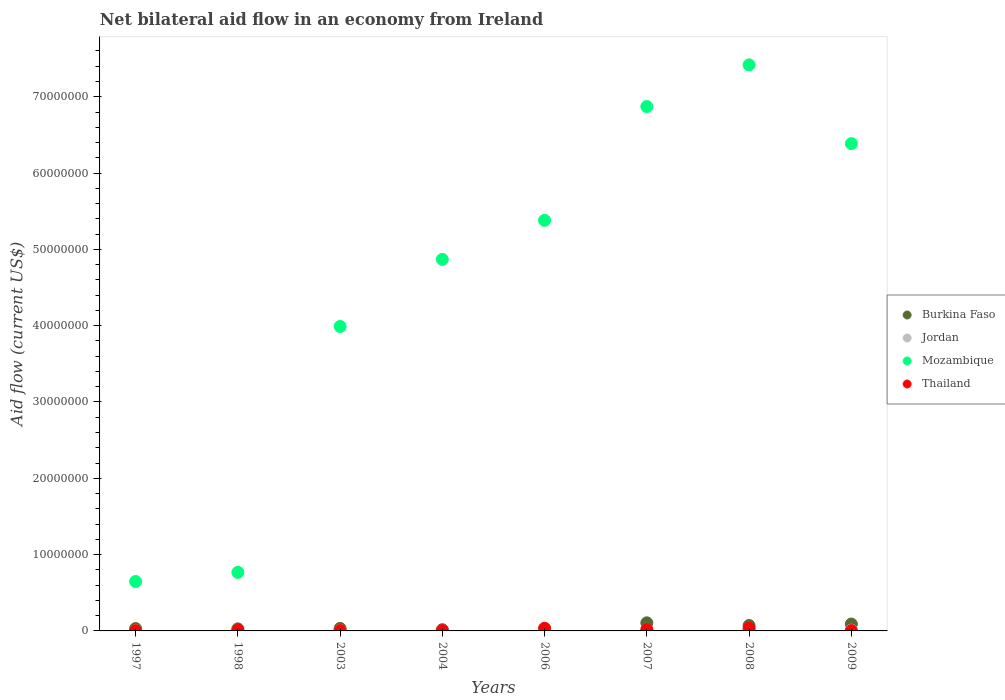How many different coloured dotlines are there?
Provide a short and direct response. 4. Is the number of dotlines equal to the number of legend labels?
Provide a short and direct response. Yes. Across all years, what is the maximum net bilateral aid flow in Burkina Faso?
Your answer should be very brief. 1.06e+06. In which year was the net bilateral aid flow in Mozambique maximum?
Ensure brevity in your answer.  2008. In which year was the net bilateral aid flow in Jordan minimum?
Ensure brevity in your answer.  1998. What is the total net bilateral aid flow in Mozambique in the graph?
Your answer should be very brief. 3.63e+08. What is the difference between the net bilateral aid flow in Burkina Faso in 2006 and the net bilateral aid flow in Thailand in 2004?
Ensure brevity in your answer.  3.00e+04. What is the average net bilateral aid flow in Mozambique per year?
Your response must be concise. 4.54e+07. In the year 2008, what is the difference between the net bilateral aid flow in Jordan and net bilateral aid flow in Burkina Faso?
Provide a succinct answer. -5.70e+05. What is the ratio of the net bilateral aid flow in Thailand in 1997 to that in 1998?
Provide a short and direct response. 0.4. Is the net bilateral aid flow in Burkina Faso in 2003 less than that in 2007?
Provide a succinct answer. Yes. What is the difference between the highest and the second highest net bilateral aid flow in Burkina Faso?
Your response must be concise. 1.60e+05. Is it the case that in every year, the sum of the net bilateral aid flow in Mozambique and net bilateral aid flow in Jordan  is greater than the net bilateral aid flow in Thailand?
Your answer should be very brief. Yes. Does the net bilateral aid flow in Burkina Faso monotonically increase over the years?
Your response must be concise. No. Is the net bilateral aid flow in Jordan strictly less than the net bilateral aid flow in Burkina Faso over the years?
Keep it short and to the point. No. How many years are there in the graph?
Offer a very short reply. 8. What is the difference between two consecutive major ticks on the Y-axis?
Offer a very short reply. 1.00e+07. Does the graph contain any zero values?
Offer a terse response. No. Does the graph contain grids?
Keep it short and to the point. No. Where does the legend appear in the graph?
Ensure brevity in your answer.  Center right. How many legend labels are there?
Your response must be concise. 4. How are the legend labels stacked?
Make the answer very short. Vertical. What is the title of the graph?
Your answer should be compact. Net bilateral aid flow in an economy from Ireland. Does "Serbia" appear as one of the legend labels in the graph?
Offer a very short reply. No. What is the Aid flow (current US$) in Mozambique in 1997?
Your answer should be compact. 6.48e+06. What is the Aid flow (current US$) of Jordan in 1998?
Your answer should be compact. 10000. What is the Aid flow (current US$) of Mozambique in 1998?
Offer a very short reply. 7.67e+06. What is the Aid flow (current US$) of Thailand in 1998?
Keep it short and to the point. 1.00e+05. What is the Aid flow (current US$) in Jordan in 2003?
Provide a short and direct response. 6.00e+04. What is the Aid flow (current US$) in Mozambique in 2003?
Offer a terse response. 3.99e+07. What is the Aid flow (current US$) of Jordan in 2004?
Make the answer very short. 10000. What is the Aid flow (current US$) of Mozambique in 2004?
Keep it short and to the point. 4.87e+07. What is the Aid flow (current US$) in Thailand in 2004?
Your response must be concise. 5.00e+04. What is the Aid flow (current US$) in Mozambique in 2006?
Your answer should be compact. 5.38e+07. What is the Aid flow (current US$) in Burkina Faso in 2007?
Ensure brevity in your answer.  1.06e+06. What is the Aid flow (current US$) of Mozambique in 2007?
Provide a short and direct response. 6.87e+07. What is the Aid flow (current US$) in Burkina Faso in 2008?
Your answer should be very brief. 7.10e+05. What is the Aid flow (current US$) in Mozambique in 2008?
Offer a very short reply. 7.42e+07. What is the Aid flow (current US$) of Thailand in 2008?
Keep it short and to the point. 3.50e+05. What is the Aid flow (current US$) of Jordan in 2009?
Make the answer very short. 1.00e+05. What is the Aid flow (current US$) of Mozambique in 2009?
Make the answer very short. 6.39e+07. Across all years, what is the maximum Aid flow (current US$) in Burkina Faso?
Provide a short and direct response. 1.06e+06. Across all years, what is the maximum Aid flow (current US$) of Mozambique?
Offer a very short reply. 7.42e+07. Across all years, what is the maximum Aid flow (current US$) of Thailand?
Make the answer very short. 3.50e+05. Across all years, what is the minimum Aid flow (current US$) of Burkina Faso?
Provide a succinct answer. 8.00e+04. Across all years, what is the minimum Aid flow (current US$) of Jordan?
Offer a very short reply. 10000. Across all years, what is the minimum Aid flow (current US$) of Mozambique?
Offer a terse response. 6.48e+06. What is the total Aid flow (current US$) of Burkina Faso in the graph?
Keep it short and to the point. 3.82e+06. What is the total Aid flow (current US$) in Jordan in the graph?
Make the answer very short. 7.50e+05. What is the total Aid flow (current US$) in Mozambique in the graph?
Make the answer very short. 3.63e+08. What is the total Aid flow (current US$) in Thailand in the graph?
Make the answer very short. 1.16e+06. What is the difference between the Aid flow (current US$) of Mozambique in 1997 and that in 1998?
Ensure brevity in your answer.  -1.19e+06. What is the difference between the Aid flow (current US$) in Burkina Faso in 1997 and that in 2003?
Provide a short and direct response. -2.00e+04. What is the difference between the Aid flow (current US$) of Jordan in 1997 and that in 2003?
Give a very brief answer. -2.00e+04. What is the difference between the Aid flow (current US$) of Mozambique in 1997 and that in 2003?
Give a very brief answer. -3.34e+07. What is the difference between the Aid flow (current US$) of Thailand in 1997 and that in 2003?
Make the answer very short. -10000. What is the difference between the Aid flow (current US$) of Burkina Faso in 1997 and that in 2004?
Ensure brevity in your answer.  1.50e+05. What is the difference between the Aid flow (current US$) in Mozambique in 1997 and that in 2004?
Offer a very short reply. -4.22e+07. What is the difference between the Aid flow (current US$) of Burkina Faso in 1997 and that in 2006?
Offer a very short reply. 2.30e+05. What is the difference between the Aid flow (current US$) in Jordan in 1997 and that in 2006?
Provide a short and direct response. -2.10e+05. What is the difference between the Aid flow (current US$) of Mozambique in 1997 and that in 2006?
Provide a succinct answer. -4.73e+07. What is the difference between the Aid flow (current US$) of Thailand in 1997 and that in 2006?
Offer a very short reply. -3.10e+05. What is the difference between the Aid flow (current US$) of Burkina Faso in 1997 and that in 2007?
Keep it short and to the point. -7.50e+05. What is the difference between the Aid flow (current US$) of Jordan in 1997 and that in 2007?
Give a very brief answer. -1.00e+05. What is the difference between the Aid flow (current US$) in Mozambique in 1997 and that in 2007?
Your answer should be very brief. -6.22e+07. What is the difference between the Aid flow (current US$) in Thailand in 1997 and that in 2007?
Your answer should be very brief. -1.40e+05. What is the difference between the Aid flow (current US$) in Burkina Faso in 1997 and that in 2008?
Offer a very short reply. -4.00e+05. What is the difference between the Aid flow (current US$) of Jordan in 1997 and that in 2008?
Your response must be concise. -1.00e+05. What is the difference between the Aid flow (current US$) of Mozambique in 1997 and that in 2008?
Offer a terse response. -6.77e+07. What is the difference between the Aid flow (current US$) of Thailand in 1997 and that in 2008?
Your answer should be very brief. -3.10e+05. What is the difference between the Aid flow (current US$) of Burkina Faso in 1997 and that in 2009?
Ensure brevity in your answer.  -5.90e+05. What is the difference between the Aid flow (current US$) in Jordan in 1997 and that in 2009?
Give a very brief answer. -6.00e+04. What is the difference between the Aid flow (current US$) of Mozambique in 1997 and that in 2009?
Provide a short and direct response. -5.74e+07. What is the difference between the Aid flow (current US$) in Mozambique in 1998 and that in 2003?
Offer a very short reply. -3.22e+07. What is the difference between the Aid flow (current US$) in Thailand in 1998 and that in 2003?
Keep it short and to the point. 5.00e+04. What is the difference between the Aid flow (current US$) in Burkina Faso in 1998 and that in 2004?
Keep it short and to the point. 1.10e+05. What is the difference between the Aid flow (current US$) in Jordan in 1998 and that in 2004?
Keep it short and to the point. 0. What is the difference between the Aid flow (current US$) in Mozambique in 1998 and that in 2004?
Make the answer very short. -4.10e+07. What is the difference between the Aid flow (current US$) of Burkina Faso in 1998 and that in 2006?
Keep it short and to the point. 1.90e+05. What is the difference between the Aid flow (current US$) in Jordan in 1998 and that in 2006?
Your answer should be very brief. -2.40e+05. What is the difference between the Aid flow (current US$) of Mozambique in 1998 and that in 2006?
Make the answer very short. -4.61e+07. What is the difference between the Aid flow (current US$) of Thailand in 1998 and that in 2006?
Keep it short and to the point. -2.50e+05. What is the difference between the Aid flow (current US$) of Burkina Faso in 1998 and that in 2007?
Keep it short and to the point. -7.90e+05. What is the difference between the Aid flow (current US$) of Jordan in 1998 and that in 2007?
Keep it short and to the point. -1.30e+05. What is the difference between the Aid flow (current US$) of Mozambique in 1998 and that in 2007?
Provide a succinct answer. -6.10e+07. What is the difference between the Aid flow (current US$) in Thailand in 1998 and that in 2007?
Give a very brief answer. -8.00e+04. What is the difference between the Aid flow (current US$) of Burkina Faso in 1998 and that in 2008?
Make the answer very short. -4.40e+05. What is the difference between the Aid flow (current US$) in Jordan in 1998 and that in 2008?
Offer a terse response. -1.30e+05. What is the difference between the Aid flow (current US$) of Mozambique in 1998 and that in 2008?
Keep it short and to the point. -6.65e+07. What is the difference between the Aid flow (current US$) in Burkina Faso in 1998 and that in 2009?
Keep it short and to the point. -6.30e+05. What is the difference between the Aid flow (current US$) of Jordan in 1998 and that in 2009?
Your answer should be very brief. -9.00e+04. What is the difference between the Aid flow (current US$) of Mozambique in 1998 and that in 2009?
Your answer should be very brief. -5.62e+07. What is the difference between the Aid flow (current US$) in Thailand in 1998 and that in 2009?
Your answer should be very brief. 6.00e+04. What is the difference between the Aid flow (current US$) of Mozambique in 2003 and that in 2004?
Your answer should be compact. -8.79e+06. What is the difference between the Aid flow (current US$) of Mozambique in 2003 and that in 2006?
Your answer should be compact. -1.39e+07. What is the difference between the Aid flow (current US$) of Thailand in 2003 and that in 2006?
Your answer should be compact. -3.00e+05. What is the difference between the Aid flow (current US$) in Burkina Faso in 2003 and that in 2007?
Your answer should be compact. -7.30e+05. What is the difference between the Aid flow (current US$) in Jordan in 2003 and that in 2007?
Your response must be concise. -8.00e+04. What is the difference between the Aid flow (current US$) of Mozambique in 2003 and that in 2007?
Ensure brevity in your answer.  -2.88e+07. What is the difference between the Aid flow (current US$) in Thailand in 2003 and that in 2007?
Provide a short and direct response. -1.30e+05. What is the difference between the Aid flow (current US$) of Burkina Faso in 2003 and that in 2008?
Your answer should be very brief. -3.80e+05. What is the difference between the Aid flow (current US$) of Mozambique in 2003 and that in 2008?
Your response must be concise. -3.43e+07. What is the difference between the Aid flow (current US$) in Thailand in 2003 and that in 2008?
Ensure brevity in your answer.  -3.00e+05. What is the difference between the Aid flow (current US$) in Burkina Faso in 2003 and that in 2009?
Make the answer very short. -5.70e+05. What is the difference between the Aid flow (current US$) in Mozambique in 2003 and that in 2009?
Ensure brevity in your answer.  -2.40e+07. What is the difference between the Aid flow (current US$) of Thailand in 2003 and that in 2009?
Ensure brevity in your answer.  10000. What is the difference between the Aid flow (current US$) in Mozambique in 2004 and that in 2006?
Your answer should be very brief. -5.12e+06. What is the difference between the Aid flow (current US$) of Thailand in 2004 and that in 2006?
Give a very brief answer. -3.00e+05. What is the difference between the Aid flow (current US$) of Burkina Faso in 2004 and that in 2007?
Offer a very short reply. -9.00e+05. What is the difference between the Aid flow (current US$) of Jordan in 2004 and that in 2007?
Offer a very short reply. -1.30e+05. What is the difference between the Aid flow (current US$) in Mozambique in 2004 and that in 2007?
Provide a short and direct response. -2.00e+07. What is the difference between the Aid flow (current US$) in Burkina Faso in 2004 and that in 2008?
Your response must be concise. -5.50e+05. What is the difference between the Aid flow (current US$) of Jordan in 2004 and that in 2008?
Keep it short and to the point. -1.30e+05. What is the difference between the Aid flow (current US$) in Mozambique in 2004 and that in 2008?
Make the answer very short. -2.55e+07. What is the difference between the Aid flow (current US$) in Thailand in 2004 and that in 2008?
Make the answer very short. -3.00e+05. What is the difference between the Aid flow (current US$) of Burkina Faso in 2004 and that in 2009?
Your response must be concise. -7.40e+05. What is the difference between the Aid flow (current US$) of Mozambique in 2004 and that in 2009?
Your answer should be compact. -1.52e+07. What is the difference between the Aid flow (current US$) in Thailand in 2004 and that in 2009?
Make the answer very short. 10000. What is the difference between the Aid flow (current US$) of Burkina Faso in 2006 and that in 2007?
Provide a short and direct response. -9.80e+05. What is the difference between the Aid flow (current US$) in Mozambique in 2006 and that in 2007?
Your response must be concise. -1.49e+07. What is the difference between the Aid flow (current US$) of Burkina Faso in 2006 and that in 2008?
Your response must be concise. -6.30e+05. What is the difference between the Aid flow (current US$) of Mozambique in 2006 and that in 2008?
Keep it short and to the point. -2.04e+07. What is the difference between the Aid flow (current US$) in Burkina Faso in 2006 and that in 2009?
Keep it short and to the point. -8.20e+05. What is the difference between the Aid flow (current US$) of Jordan in 2006 and that in 2009?
Give a very brief answer. 1.50e+05. What is the difference between the Aid flow (current US$) of Mozambique in 2006 and that in 2009?
Offer a very short reply. -1.00e+07. What is the difference between the Aid flow (current US$) of Thailand in 2006 and that in 2009?
Offer a very short reply. 3.10e+05. What is the difference between the Aid flow (current US$) of Burkina Faso in 2007 and that in 2008?
Your answer should be compact. 3.50e+05. What is the difference between the Aid flow (current US$) of Mozambique in 2007 and that in 2008?
Ensure brevity in your answer.  -5.46e+06. What is the difference between the Aid flow (current US$) in Thailand in 2007 and that in 2008?
Ensure brevity in your answer.  -1.70e+05. What is the difference between the Aid flow (current US$) in Burkina Faso in 2007 and that in 2009?
Provide a short and direct response. 1.60e+05. What is the difference between the Aid flow (current US$) of Jordan in 2007 and that in 2009?
Keep it short and to the point. 4.00e+04. What is the difference between the Aid flow (current US$) in Mozambique in 2007 and that in 2009?
Your answer should be very brief. 4.86e+06. What is the difference between the Aid flow (current US$) of Thailand in 2007 and that in 2009?
Keep it short and to the point. 1.40e+05. What is the difference between the Aid flow (current US$) in Burkina Faso in 2008 and that in 2009?
Give a very brief answer. -1.90e+05. What is the difference between the Aid flow (current US$) of Mozambique in 2008 and that in 2009?
Provide a succinct answer. 1.03e+07. What is the difference between the Aid flow (current US$) in Burkina Faso in 1997 and the Aid flow (current US$) in Jordan in 1998?
Your answer should be very brief. 3.00e+05. What is the difference between the Aid flow (current US$) in Burkina Faso in 1997 and the Aid flow (current US$) in Mozambique in 1998?
Your answer should be very brief. -7.36e+06. What is the difference between the Aid flow (current US$) of Jordan in 1997 and the Aid flow (current US$) of Mozambique in 1998?
Give a very brief answer. -7.63e+06. What is the difference between the Aid flow (current US$) of Jordan in 1997 and the Aid flow (current US$) of Thailand in 1998?
Give a very brief answer. -6.00e+04. What is the difference between the Aid flow (current US$) of Mozambique in 1997 and the Aid flow (current US$) of Thailand in 1998?
Offer a very short reply. 6.38e+06. What is the difference between the Aid flow (current US$) in Burkina Faso in 1997 and the Aid flow (current US$) in Mozambique in 2003?
Your answer should be compact. -3.96e+07. What is the difference between the Aid flow (current US$) in Jordan in 1997 and the Aid flow (current US$) in Mozambique in 2003?
Your answer should be compact. -3.99e+07. What is the difference between the Aid flow (current US$) in Jordan in 1997 and the Aid flow (current US$) in Thailand in 2003?
Ensure brevity in your answer.  -10000. What is the difference between the Aid flow (current US$) in Mozambique in 1997 and the Aid flow (current US$) in Thailand in 2003?
Offer a terse response. 6.43e+06. What is the difference between the Aid flow (current US$) in Burkina Faso in 1997 and the Aid flow (current US$) in Mozambique in 2004?
Make the answer very short. -4.84e+07. What is the difference between the Aid flow (current US$) in Jordan in 1997 and the Aid flow (current US$) in Mozambique in 2004?
Ensure brevity in your answer.  -4.86e+07. What is the difference between the Aid flow (current US$) of Mozambique in 1997 and the Aid flow (current US$) of Thailand in 2004?
Provide a succinct answer. 6.43e+06. What is the difference between the Aid flow (current US$) of Burkina Faso in 1997 and the Aid flow (current US$) of Jordan in 2006?
Offer a very short reply. 6.00e+04. What is the difference between the Aid flow (current US$) of Burkina Faso in 1997 and the Aid flow (current US$) of Mozambique in 2006?
Your response must be concise. -5.35e+07. What is the difference between the Aid flow (current US$) of Jordan in 1997 and the Aid flow (current US$) of Mozambique in 2006?
Make the answer very short. -5.38e+07. What is the difference between the Aid flow (current US$) in Jordan in 1997 and the Aid flow (current US$) in Thailand in 2006?
Your answer should be very brief. -3.10e+05. What is the difference between the Aid flow (current US$) of Mozambique in 1997 and the Aid flow (current US$) of Thailand in 2006?
Offer a very short reply. 6.13e+06. What is the difference between the Aid flow (current US$) of Burkina Faso in 1997 and the Aid flow (current US$) of Mozambique in 2007?
Provide a succinct answer. -6.84e+07. What is the difference between the Aid flow (current US$) of Burkina Faso in 1997 and the Aid flow (current US$) of Thailand in 2007?
Your response must be concise. 1.30e+05. What is the difference between the Aid flow (current US$) in Jordan in 1997 and the Aid flow (current US$) in Mozambique in 2007?
Offer a very short reply. -6.87e+07. What is the difference between the Aid flow (current US$) in Jordan in 1997 and the Aid flow (current US$) in Thailand in 2007?
Make the answer very short. -1.40e+05. What is the difference between the Aid flow (current US$) of Mozambique in 1997 and the Aid flow (current US$) of Thailand in 2007?
Offer a very short reply. 6.30e+06. What is the difference between the Aid flow (current US$) in Burkina Faso in 1997 and the Aid flow (current US$) in Jordan in 2008?
Offer a terse response. 1.70e+05. What is the difference between the Aid flow (current US$) of Burkina Faso in 1997 and the Aid flow (current US$) of Mozambique in 2008?
Your answer should be very brief. -7.39e+07. What is the difference between the Aid flow (current US$) in Jordan in 1997 and the Aid flow (current US$) in Mozambique in 2008?
Offer a terse response. -7.41e+07. What is the difference between the Aid flow (current US$) of Jordan in 1997 and the Aid flow (current US$) of Thailand in 2008?
Offer a terse response. -3.10e+05. What is the difference between the Aid flow (current US$) of Mozambique in 1997 and the Aid flow (current US$) of Thailand in 2008?
Ensure brevity in your answer.  6.13e+06. What is the difference between the Aid flow (current US$) in Burkina Faso in 1997 and the Aid flow (current US$) in Mozambique in 2009?
Your answer should be compact. -6.36e+07. What is the difference between the Aid flow (current US$) in Jordan in 1997 and the Aid flow (current US$) in Mozambique in 2009?
Your answer should be compact. -6.38e+07. What is the difference between the Aid flow (current US$) of Jordan in 1997 and the Aid flow (current US$) of Thailand in 2009?
Offer a terse response. 0. What is the difference between the Aid flow (current US$) of Mozambique in 1997 and the Aid flow (current US$) of Thailand in 2009?
Keep it short and to the point. 6.44e+06. What is the difference between the Aid flow (current US$) in Burkina Faso in 1998 and the Aid flow (current US$) in Jordan in 2003?
Offer a terse response. 2.10e+05. What is the difference between the Aid flow (current US$) in Burkina Faso in 1998 and the Aid flow (current US$) in Mozambique in 2003?
Your answer should be compact. -3.96e+07. What is the difference between the Aid flow (current US$) of Burkina Faso in 1998 and the Aid flow (current US$) of Thailand in 2003?
Make the answer very short. 2.20e+05. What is the difference between the Aid flow (current US$) of Jordan in 1998 and the Aid flow (current US$) of Mozambique in 2003?
Provide a short and direct response. -3.99e+07. What is the difference between the Aid flow (current US$) in Mozambique in 1998 and the Aid flow (current US$) in Thailand in 2003?
Give a very brief answer. 7.62e+06. What is the difference between the Aid flow (current US$) in Burkina Faso in 1998 and the Aid flow (current US$) in Mozambique in 2004?
Offer a terse response. -4.84e+07. What is the difference between the Aid flow (current US$) of Jordan in 1998 and the Aid flow (current US$) of Mozambique in 2004?
Offer a terse response. -4.87e+07. What is the difference between the Aid flow (current US$) in Jordan in 1998 and the Aid flow (current US$) in Thailand in 2004?
Offer a terse response. -4.00e+04. What is the difference between the Aid flow (current US$) in Mozambique in 1998 and the Aid flow (current US$) in Thailand in 2004?
Provide a short and direct response. 7.62e+06. What is the difference between the Aid flow (current US$) of Burkina Faso in 1998 and the Aid flow (current US$) of Mozambique in 2006?
Provide a short and direct response. -5.35e+07. What is the difference between the Aid flow (current US$) of Burkina Faso in 1998 and the Aid flow (current US$) of Thailand in 2006?
Your answer should be very brief. -8.00e+04. What is the difference between the Aid flow (current US$) of Jordan in 1998 and the Aid flow (current US$) of Mozambique in 2006?
Make the answer very short. -5.38e+07. What is the difference between the Aid flow (current US$) of Jordan in 1998 and the Aid flow (current US$) of Thailand in 2006?
Your answer should be very brief. -3.40e+05. What is the difference between the Aid flow (current US$) in Mozambique in 1998 and the Aid flow (current US$) in Thailand in 2006?
Ensure brevity in your answer.  7.32e+06. What is the difference between the Aid flow (current US$) in Burkina Faso in 1998 and the Aid flow (current US$) in Mozambique in 2007?
Keep it short and to the point. -6.84e+07. What is the difference between the Aid flow (current US$) of Jordan in 1998 and the Aid flow (current US$) of Mozambique in 2007?
Offer a very short reply. -6.87e+07. What is the difference between the Aid flow (current US$) in Jordan in 1998 and the Aid flow (current US$) in Thailand in 2007?
Your answer should be very brief. -1.70e+05. What is the difference between the Aid flow (current US$) in Mozambique in 1998 and the Aid flow (current US$) in Thailand in 2007?
Provide a short and direct response. 7.49e+06. What is the difference between the Aid flow (current US$) in Burkina Faso in 1998 and the Aid flow (current US$) in Jordan in 2008?
Your answer should be compact. 1.30e+05. What is the difference between the Aid flow (current US$) of Burkina Faso in 1998 and the Aid flow (current US$) of Mozambique in 2008?
Your answer should be compact. -7.39e+07. What is the difference between the Aid flow (current US$) of Jordan in 1998 and the Aid flow (current US$) of Mozambique in 2008?
Your answer should be very brief. -7.42e+07. What is the difference between the Aid flow (current US$) of Jordan in 1998 and the Aid flow (current US$) of Thailand in 2008?
Your response must be concise. -3.40e+05. What is the difference between the Aid flow (current US$) of Mozambique in 1998 and the Aid flow (current US$) of Thailand in 2008?
Make the answer very short. 7.32e+06. What is the difference between the Aid flow (current US$) in Burkina Faso in 1998 and the Aid flow (current US$) in Mozambique in 2009?
Your response must be concise. -6.36e+07. What is the difference between the Aid flow (current US$) of Burkina Faso in 1998 and the Aid flow (current US$) of Thailand in 2009?
Give a very brief answer. 2.30e+05. What is the difference between the Aid flow (current US$) in Jordan in 1998 and the Aid flow (current US$) in Mozambique in 2009?
Your answer should be compact. -6.38e+07. What is the difference between the Aid flow (current US$) in Jordan in 1998 and the Aid flow (current US$) in Thailand in 2009?
Keep it short and to the point. -3.00e+04. What is the difference between the Aid flow (current US$) in Mozambique in 1998 and the Aid flow (current US$) in Thailand in 2009?
Your answer should be very brief. 7.63e+06. What is the difference between the Aid flow (current US$) in Burkina Faso in 2003 and the Aid flow (current US$) in Jordan in 2004?
Make the answer very short. 3.20e+05. What is the difference between the Aid flow (current US$) in Burkina Faso in 2003 and the Aid flow (current US$) in Mozambique in 2004?
Offer a very short reply. -4.84e+07. What is the difference between the Aid flow (current US$) in Burkina Faso in 2003 and the Aid flow (current US$) in Thailand in 2004?
Your response must be concise. 2.80e+05. What is the difference between the Aid flow (current US$) in Jordan in 2003 and the Aid flow (current US$) in Mozambique in 2004?
Provide a succinct answer. -4.86e+07. What is the difference between the Aid flow (current US$) of Jordan in 2003 and the Aid flow (current US$) of Thailand in 2004?
Ensure brevity in your answer.  10000. What is the difference between the Aid flow (current US$) in Mozambique in 2003 and the Aid flow (current US$) in Thailand in 2004?
Offer a terse response. 3.98e+07. What is the difference between the Aid flow (current US$) of Burkina Faso in 2003 and the Aid flow (current US$) of Mozambique in 2006?
Offer a very short reply. -5.35e+07. What is the difference between the Aid flow (current US$) of Burkina Faso in 2003 and the Aid flow (current US$) of Thailand in 2006?
Provide a short and direct response. -2.00e+04. What is the difference between the Aid flow (current US$) in Jordan in 2003 and the Aid flow (current US$) in Mozambique in 2006?
Provide a succinct answer. -5.38e+07. What is the difference between the Aid flow (current US$) in Jordan in 2003 and the Aid flow (current US$) in Thailand in 2006?
Keep it short and to the point. -2.90e+05. What is the difference between the Aid flow (current US$) in Mozambique in 2003 and the Aid flow (current US$) in Thailand in 2006?
Your answer should be compact. 3.96e+07. What is the difference between the Aid flow (current US$) in Burkina Faso in 2003 and the Aid flow (current US$) in Jordan in 2007?
Your answer should be compact. 1.90e+05. What is the difference between the Aid flow (current US$) in Burkina Faso in 2003 and the Aid flow (current US$) in Mozambique in 2007?
Provide a succinct answer. -6.84e+07. What is the difference between the Aid flow (current US$) in Jordan in 2003 and the Aid flow (current US$) in Mozambique in 2007?
Offer a very short reply. -6.87e+07. What is the difference between the Aid flow (current US$) in Jordan in 2003 and the Aid flow (current US$) in Thailand in 2007?
Offer a terse response. -1.20e+05. What is the difference between the Aid flow (current US$) of Mozambique in 2003 and the Aid flow (current US$) of Thailand in 2007?
Your response must be concise. 3.97e+07. What is the difference between the Aid flow (current US$) of Burkina Faso in 2003 and the Aid flow (current US$) of Jordan in 2008?
Provide a succinct answer. 1.90e+05. What is the difference between the Aid flow (current US$) in Burkina Faso in 2003 and the Aid flow (current US$) in Mozambique in 2008?
Keep it short and to the point. -7.38e+07. What is the difference between the Aid flow (current US$) of Jordan in 2003 and the Aid flow (current US$) of Mozambique in 2008?
Make the answer very short. -7.41e+07. What is the difference between the Aid flow (current US$) in Jordan in 2003 and the Aid flow (current US$) in Thailand in 2008?
Provide a succinct answer. -2.90e+05. What is the difference between the Aid flow (current US$) of Mozambique in 2003 and the Aid flow (current US$) of Thailand in 2008?
Your answer should be very brief. 3.96e+07. What is the difference between the Aid flow (current US$) in Burkina Faso in 2003 and the Aid flow (current US$) in Jordan in 2009?
Your answer should be very brief. 2.30e+05. What is the difference between the Aid flow (current US$) of Burkina Faso in 2003 and the Aid flow (current US$) of Mozambique in 2009?
Your response must be concise. -6.35e+07. What is the difference between the Aid flow (current US$) of Burkina Faso in 2003 and the Aid flow (current US$) of Thailand in 2009?
Your answer should be very brief. 2.90e+05. What is the difference between the Aid flow (current US$) of Jordan in 2003 and the Aid flow (current US$) of Mozambique in 2009?
Offer a terse response. -6.38e+07. What is the difference between the Aid flow (current US$) in Jordan in 2003 and the Aid flow (current US$) in Thailand in 2009?
Make the answer very short. 2.00e+04. What is the difference between the Aid flow (current US$) in Mozambique in 2003 and the Aid flow (current US$) in Thailand in 2009?
Your answer should be compact. 3.99e+07. What is the difference between the Aid flow (current US$) in Burkina Faso in 2004 and the Aid flow (current US$) in Jordan in 2006?
Provide a short and direct response. -9.00e+04. What is the difference between the Aid flow (current US$) of Burkina Faso in 2004 and the Aid flow (current US$) of Mozambique in 2006?
Offer a very short reply. -5.36e+07. What is the difference between the Aid flow (current US$) of Burkina Faso in 2004 and the Aid flow (current US$) of Thailand in 2006?
Give a very brief answer. -1.90e+05. What is the difference between the Aid flow (current US$) in Jordan in 2004 and the Aid flow (current US$) in Mozambique in 2006?
Provide a succinct answer. -5.38e+07. What is the difference between the Aid flow (current US$) in Jordan in 2004 and the Aid flow (current US$) in Thailand in 2006?
Provide a short and direct response. -3.40e+05. What is the difference between the Aid flow (current US$) of Mozambique in 2004 and the Aid flow (current US$) of Thailand in 2006?
Give a very brief answer. 4.83e+07. What is the difference between the Aid flow (current US$) in Burkina Faso in 2004 and the Aid flow (current US$) in Jordan in 2007?
Make the answer very short. 2.00e+04. What is the difference between the Aid flow (current US$) of Burkina Faso in 2004 and the Aid flow (current US$) of Mozambique in 2007?
Give a very brief answer. -6.86e+07. What is the difference between the Aid flow (current US$) of Jordan in 2004 and the Aid flow (current US$) of Mozambique in 2007?
Your response must be concise. -6.87e+07. What is the difference between the Aid flow (current US$) in Mozambique in 2004 and the Aid flow (current US$) in Thailand in 2007?
Make the answer very short. 4.85e+07. What is the difference between the Aid flow (current US$) in Burkina Faso in 2004 and the Aid flow (current US$) in Mozambique in 2008?
Keep it short and to the point. -7.40e+07. What is the difference between the Aid flow (current US$) in Jordan in 2004 and the Aid flow (current US$) in Mozambique in 2008?
Your answer should be compact. -7.42e+07. What is the difference between the Aid flow (current US$) in Jordan in 2004 and the Aid flow (current US$) in Thailand in 2008?
Your answer should be compact. -3.40e+05. What is the difference between the Aid flow (current US$) of Mozambique in 2004 and the Aid flow (current US$) of Thailand in 2008?
Your answer should be compact. 4.83e+07. What is the difference between the Aid flow (current US$) in Burkina Faso in 2004 and the Aid flow (current US$) in Mozambique in 2009?
Your answer should be very brief. -6.37e+07. What is the difference between the Aid flow (current US$) in Burkina Faso in 2004 and the Aid flow (current US$) in Thailand in 2009?
Your answer should be compact. 1.20e+05. What is the difference between the Aid flow (current US$) in Jordan in 2004 and the Aid flow (current US$) in Mozambique in 2009?
Provide a succinct answer. -6.38e+07. What is the difference between the Aid flow (current US$) in Mozambique in 2004 and the Aid flow (current US$) in Thailand in 2009?
Provide a succinct answer. 4.86e+07. What is the difference between the Aid flow (current US$) of Burkina Faso in 2006 and the Aid flow (current US$) of Mozambique in 2007?
Make the answer very short. -6.86e+07. What is the difference between the Aid flow (current US$) of Jordan in 2006 and the Aid flow (current US$) of Mozambique in 2007?
Make the answer very short. -6.85e+07. What is the difference between the Aid flow (current US$) in Jordan in 2006 and the Aid flow (current US$) in Thailand in 2007?
Make the answer very short. 7.00e+04. What is the difference between the Aid flow (current US$) in Mozambique in 2006 and the Aid flow (current US$) in Thailand in 2007?
Offer a very short reply. 5.36e+07. What is the difference between the Aid flow (current US$) of Burkina Faso in 2006 and the Aid flow (current US$) of Jordan in 2008?
Make the answer very short. -6.00e+04. What is the difference between the Aid flow (current US$) in Burkina Faso in 2006 and the Aid flow (current US$) in Mozambique in 2008?
Offer a terse response. -7.41e+07. What is the difference between the Aid flow (current US$) of Burkina Faso in 2006 and the Aid flow (current US$) of Thailand in 2008?
Provide a succinct answer. -2.70e+05. What is the difference between the Aid flow (current US$) of Jordan in 2006 and the Aid flow (current US$) of Mozambique in 2008?
Provide a succinct answer. -7.39e+07. What is the difference between the Aid flow (current US$) of Mozambique in 2006 and the Aid flow (current US$) of Thailand in 2008?
Keep it short and to the point. 5.35e+07. What is the difference between the Aid flow (current US$) in Burkina Faso in 2006 and the Aid flow (current US$) in Jordan in 2009?
Provide a short and direct response. -2.00e+04. What is the difference between the Aid flow (current US$) of Burkina Faso in 2006 and the Aid flow (current US$) of Mozambique in 2009?
Your answer should be compact. -6.38e+07. What is the difference between the Aid flow (current US$) of Jordan in 2006 and the Aid flow (current US$) of Mozambique in 2009?
Provide a short and direct response. -6.36e+07. What is the difference between the Aid flow (current US$) in Mozambique in 2006 and the Aid flow (current US$) in Thailand in 2009?
Ensure brevity in your answer.  5.38e+07. What is the difference between the Aid flow (current US$) in Burkina Faso in 2007 and the Aid flow (current US$) in Jordan in 2008?
Your answer should be compact. 9.20e+05. What is the difference between the Aid flow (current US$) in Burkina Faso in 2007 and the Aid flow (current US$) in Mozambique in 2008?
Give a very brief answer. -7.31e+07. What is the difference between the Aid flow (current US$) in Burkina Faso in 2007 and the Aid flow (current US$) in Thailand in 2008?
Your answer should be very brief. 7.10e+05. What is the difference between the Aid flow (current US$) in Jordan in 2007 and the Aid flow (current US$) in Mozambique in 2008?
Ensure brevity in your answer.  -7.40e+07. What is the difference between the Aid flow (current US$) in Jordan in 2007 and the Aid flow (current US$) in Thailand in 2008?
Your answer should be very brief. -2.10e+05. What is the difference between the Aid flow (current US$) in Mozambique in 2007 and the Aid flow (current US$) in Thailand in 2008?
Your answer should be very brief. 6.84e+07. What is the difference between the Aid flow (current US$) in Burkina Faso in 2007 and the Aid flow (current US$) in Jordan in 2009?
Offer a very short reply. 9.60e+05. What is the difference between the Aid flow (current US$) in Burkina Faso in 2007 and the Aid flow (current US$) in Mozambique in 2009?
Provide a short and direct response. -6.28e+07. What is the difference between the Aid flow (current US$) in Burkina Faso in 2007 and the Aid flow (current US$) in Thailand in 2009?
Provide a succinct answer. 1.02e+06. What is the difference between the Aid flow (current US$) of Jordan in 2007 and the Aid flow (current US$) of Mozambique in 2009?
Keep it short and to the point. -6.37e+07. What is the difference between the Aid flow (current US$) in Jordan in 2007 and the Aid flow (current US$) in Thailand in 2009?
Your answer should be compact. 1.00e+05. What is the difference between the Aid flow (current US$) of Mozambique in 2007 and the Aid flow (current US$) of Thailand in 2009?
Your answer should be compact. 6.87e+07. What is the difference between the Aid flow (current US$) in Burkina Faso in 2008 and the Aid flow (current US$) in Jordan in 2009?
Ensure brevity in your answer.  6.10e+05. What is the difference between the Aid flow (current US$) of Burkina Faso in 2008 and the Aid flow (current US$) of Mozambique in 2009?
Your answer should be compact. -6.32e+07. What is the difference between the Aid flow (current US$) in Burkina Faso in 2008 and the Aid flow (current US$) in Thailand in 2009?
Give a very brief answer. 6.70e+05. What is the difference between the Aid flow (current US$) of Jordan in 2008 and the Aid flow (current US$) of Mozambique in 2009?
Provide a succinct answer. -6.37e+07. What is the difference between the Aid flow (current US$) of Mozambique in 2008 and the Aid flow (current US$) of Thailand in 2009?
Your answer should be very brief. 7.41e+07. What is the average Aid flow (current US$) in Burkina Faso per year?
Make the answer very short. 4.78e+05. What is the average Aid flow (current US$) of Jordan per year?
Your answer should be compact. 9.38e+04. What is the average Aid flow (current US$) of Mozambique per year?
Offer a terse response. 4.54e+07. What is the average Aid flow (current US$) of Thailand per year?
Give a very brief answer. 1.45e+05. In the year 1997, what is the difference between the Aid flow (current US$) in Burkina Faso and Aid flow (current US$) in Jordan?
Provide a succinct answer. 2.70e+05. In the year 1997, what is the difference between the Aid flow (current US$) of Burkina Faso and Aid flow (current US$) of Mozambique?
Provide a short and direct response. -6.17e+06. In the year 1997, what is the difference between the Aid flow (current US$) in Jordan and Aid flow (current US$) in Mozambique?
Offer a very short reply. -6.44e+06. In the year 1997, what is the difference between the Aid flow (current US$) in Mozambique and Aid flow (current US$) in Thailand?
Your answer should be compact. 6.44e+06. In the year 1998, what is the difference between the Aid flow (current US$) in Burkina Faso and Aid flow (current US$) in Jordan?
Offer a very short reply. 2.60e+05. In the year 1998, what is the difference between the Aid flow (current US$) in Burkina Faso and Aid flow (current US$) in Mozambique?
Provide a short and direct response. -7.40e+06. In the year 1998, what is the difference between the Aid flow (current US$) of Jordan and Aid flow (current US$) of Mozambique?
Ensure brevity in your answer.  -7.66e+06. In the year 1998, what is the difference between the Aid flow (current US$) of Mozambique and Aid flow (current US$) of Thailand?
Give a very brief answer. 7.57e+06. In the year 2003, what is the difference between the Aid flow (current US$) of Burkina Faso and Aid flow (current US$) of Mozambique?
Your response must be concise. -3.96e+07. In the year 2003, what is the difference between the Aid flow (current US$) in Jordan and Aid flow (current US$) in Mozambique?
Your answer should be very brief. -3.98e+07. In the year 2003, what is the difference between the Aid flow (current US$) in Jordan and Aid flow (current US$) in Thailand?
Ensure brevity in your answer.  10000. In the year 2003, what is the difference between the Aid flow (current US$) of Mozambique and Aid flow (current US$) of Thailand?
Your answer should be very brief. 3.98e+07. In the year 2004, what is the difference between the Aid flow (current US$) of Burkina Faso and Aid flow (current US$) of Jordan?
Your answer should be compact. 1.50e+05. In the year 2004, what is the difference between the Aid flow (current US$) of Burkina Faso and Aid flow (current US$) of Mozambique?
Provide a short and direct response. -4.85e+07. In the year 2004, what is the difference between the Aid flow (current US$) in Jordan and Aid flow (current US$) in Mozambique?
Provide a short and direct response. -4.87e+07. In the year 2004, what is the difference between the Aid flow (current US$) in Mozambique and Aid flow (current US$) in Thailand?
Your response must be concise. 4.86e+07. In the year 2006, what is the difference between the Aid flow (current US$) in Burkina Faso and Aid flow (current US$) in Jordan?
Give a very brief answer. -1.70e+05. In the year 2006, what is the difference between the Aid flow (current US$) of Burkina Faso and Aid flow (current US$) of Mozambique?
Keep it short and to the point. -5.37e+07. In the year 2006, what is the difference between the Aid flow (current US$) of Jordan and Aid flow (current US$) of Mozambique?
Your answer should be compact. -5.36e+07. In the year 2006, what is the difference between the Aid flow (current US$) of Mozambique and Aid flow (current US$) of Thailand?
Provide a short and direct response. 5.35e+07. In the year 2007, what is the difference between the Aid flow (current US$) of Burkina Faso and Aid flow (current US$) of Jordan?
Give a very brief answer. 9.20e+05. In the year 2007, what is the difference between the Aid flow (current US$) of Burkina Faso and Aid flow (current US$) of Mozambique?
Ensure brevity in your answer.  -6.77e+07. In the year 2007, what is the difference between the Aid flow (current US$) in Burkina Faso and Aid flow (current US$) in Thailand?
Provide a succinct answer. 8.80e+05. In the year 2007, what is the difference between the Aid flow (current US$) of Jordan and Aid flow (current US$) of Mozambique?
Give a very brief answer. -6.86e+07. In the year 2007, what is the difference between the Aid flow (current US$) in Jordan and Aid flow (current US$) in Thailand?
Your response must be concise. -4.00e+04. In the year 2007, what is the difference between the Aid flow (current US$) in Mozambique and Aid flow (current US$) in Thailand?
Provide a succinct answer. 6.85e+07. In the year 2008, what is the difference between the Aid flow (current US$) in Burkina Faso and Aid flow (current US$) in Jordan?
Your answer should be very brief. 5.70e+05. In the year 2008, what is the difference between the Aid flow (current US$) in Burkina Faso and Aid flow (current US$) in Mozambique?
Offer a terse response. -7.35e+07. In the year 2008, what is the difference between the Aid flow (current US$) in Burkina Faso and Aid flow (current US$) in Thailand?
Offer a very short reply. 3.60e+05. In the year 2008, what is the difference between the Aid flow (current US$) in Jordan and Aid flow (current US$) in Mozambique?
Keep it short and to the point. -7.40e+07. In the year 2008, what is the difference between the Aid flow (current US$) in Mozambique and Aid flow (current US$) in Thailand?
Provide a succinct answer. 7.38e+07. In the year 2009, what is the difference between the Aid flow (current US$) in Burkina Faso and Aid flow (current US$) in Mozambique?
Make the answer very short. -6.30e+07. In the year 2009, what is the difference between the Aid flow (current US$) of Burkina Faso and Aid flow (current US$) of Thailand?
Make the answer very short. 8.60e+05. In the year 2009, what is the difference between the Aid flow (current US$) in Jordan and Aid flow (current US$) in Mozambique?
Ensure brevity in your answer.  -6.38e+07. In the year 2009, what is the difference between the Aid flow (current US$) in Jordan and Aid flow (current US$) in Thailand?
Give a very brief answer. 6.00e+04. In the year 2009, what is the difference between the Aid flow (current US$) in Mozambique and Aid flow (current US$) in Thailand?
Offer a terse response. 6.38e+07. What is the ratio of the Aid flow (current US$) of Burkina Faso in 1997 to that in 1998?
Offer a terse response. 1.15. What is the ratio of the Aid flow (current US$) of Mozambique in 1997 to that in 1998?
Offer a very short reply. 0.84. What is the ratio of the Aid flow (current US$) in Thailand in 1997 to that in 1998?
Keep it short and to the point. 0.4. What is the ratio of the Aid flow (current US$) of Burkina Faso in 1997 to that in 2003?
Make the answer very short. 0.94. What is the ratio of the Aid flow (current US$) of Mozambique in 1997 to that in 2003?
Ensure brevity in your answer.  0.16. What is the ratio of the Aid flow (current US$) in Thailand in 1997 to that in 2003?
Your answer should be compact. 0.8. What is the ratio of the Aid flow (current US$) of Burkina Faso in 1997 to that in 2004?
Provide a short and direct response. 1.94. What is the ratio of the Aid flow (current US$) of Jordan in 1997 to that in 2004?
Provide a short and direct response. 4. What is the ratio of the Aid flow (current US$) in Mozambique in 1997 to that in 2004?
Your answer should be compact. 0.13. What is the ratio of the Aid flow (current US$) of Burkina Faso in 1997 to that in 2006?
Your answer should be very brief. 3.88. What is the ratio of the Aid flow (current US$) of Jordan in 1997 to that in 2006?
Offer a very short reply. 0.16. What is the ratio of the Aid flow (current US$) of Mozambique in 1997 to that in 2006?
Provide a short and direct response. 0.12. What is the ratio of the Aid flow (current US$) of Thailand in 1997 to that in 2006?
Your answer should be very brief. 0.11. What is the ratio of the Aid flow (current US$) of Burkina Faso in 1997 to that in 2007?
Your answer should be very brief. 0.29. What is the ratio of the Aid flow (current US$) of Jordan in 1997 to that in 2007?
Keep it short and to the point. 0.29. What is the ratio of the Aid flow (current US$) of Mozambique in 1997 to that in 2007?
Your response must be concise. 0.09. What is the ratio of the Aid flow (current US$) in Thailand in 1997 to that in 2007?
Keep it short and to the point. 0.22. What is the ratio of the Aid flow (current US$) in Burkina Faso in 1997 to that in 2008?
Your answer should be very brief. 0.44. What is the ratio of the Aid flow (current US$) of Jordan in 1997 to that in 2008?
Provide a short and direct response. 0.29. What is the ratio of the Aid flow (current US$) of Mozambique in 1997 to that in 2008?
Ensure brevity in your answer.  0.09. What is the ratio of the Aid flow (current US$) in Thailand in 1997 to that in 2008?
Your answer should be compact. 0.11. What is the ratio of the Aid flow (current US$) in Burkina Faso in 1997 to that in 2009?
Ensure brevity in your answer.  0.34. What is the ratio of the Aid flow (current US$) of Mozambique in 1997 to that in 2009?
Provide a short and direct response. 0.1. What is the ratio of the Aid flow (current US$) in Thailand in 1997 to that in 2009?
Your answer should be compact. 1. What is the ratio of the Aid flow (current US$) of Burkina Faso in 1998 to that in 2003?
Your answer should be compact. 0.82. What is the ratio of the Aid flow (current US$) in Jordan in 1998 to that in 2003?
Provide a short and direct response. 0.17. What is the ratio of the Aid flow (current US$) of Mozambique in 1998 to that in 2003?
Provide a short and direct response. 0.19. What is the ratio of the Aid flow (current US$) in Thailand in 1998 to that in 2003?
Provide a succinct answer. 2. What is the ratio of the Aid flow (current US$) in Burkina Faso in 1998 to that in 2004?
Provide a succinct answer. 1.69. What is the ratio of the Aid flow (current US$) of Jordan in 1998 to that in 2004?
Your response must be concise. 1. What is the ratio of the Aid flow (current US$) in Mozambique in 1998 to that in 2004?
Give a very brief answer. 0.16. What is the ratio of the Aid flow (current US$) in Thailand in 1998 to that in 2004?
Offer a terse response. 2. What is the ratio of the Aid flow (current US$) of Burkina Faso in 1998 to that in 2006?
Provide a short and direct response. 3.38. What is the ratio of the Aid flow (current US$) of Jordan in 1998 to that in 2006?
Your answer should be compact. 0.04. What is the ratio of the Aid flow (current US$) in Mozambique in 1998 to that in 2006?
Provide a short and direct response. 0.14. What is the ratio of the Aid flow (current US$) of Thailand in 1998 to that in 2006?
Offer a terse response. 0.29. What is the ratio of the Aid flow (current US$) in Burkina Faso in 1998 to that in 2007?
Your response must be concise. 0.25. What is the ratio of the Aid flow (current US$) of Jordan in 1998 to that in 2007?
Provide a succinct answer. 0.07. What is the ratio of the Aid flow (current US$) of Mozambique in 1998 to that in 2007?
Your response must be concise. 0.11. What is the ratio of the Aid flow (current US$) in Thailand in 1998 to that in 2007?
Ensure brevity in your answer.  0.56. What is the ratio of the Aid flow (current US$) of Burkina Faso in 1998 to that in 2008?
Your response must be concise. 0.38. What is the ratio of the Aid flow (current US$) in Jordan in 1998 to that in 2008?
Keep it short and to the point. 0.07. What is the ratio of the Aid flow (current US$) in Mozambique in 1998 to that in 2008?
Keep it short and to the point. 0.1. What is the ratio of the Aid flow (current US$) in Thailand in 1998 to that in 2008?
Make the answer very short. 0.29. What is the ratio of the Aid flow (current US$) of Burkina Faso in 1998 to that in 2009?
Ensure brevity in your answer.  0.3. What is the ratio of the Aid flow (current US$) in Mozambique in 1998 to that in 2009?
Provide a short and direct response. 0.12. What is the ratio of the Aid flow (current US$) in Burkina Faso in 2003 to that in 2004?
Your answer should be very brief. 2.06. What is the ratio of the Aid flow (current US$) of Mozambique in 2003 to that in 2004?
Offer a very short reply. 0.82. What is the ratio of the Aid flow (current US$) of Burkina Faso in 2003 to that in 2006?
Ensure brevity in your answer.  4.12. What is the ratio of the Aid flow (current US$) of Jordan in 2003 to that in 2006?
Offer a terse response. 0.24. What is the ratio of the Aid flow (current US$) of Mozambique in 2003 to that in 2006?
Offer a terse response. 0.74. What is the ratio of the Aid flow (current US$) of Thailand in 2003 to that in 2006?
Make the answer very short. 0.14. What is the ratio of the Aid flow (current US$) of Burkina Faso in 2003 to that in 2007?
Provide a short and direct response. 0.31. What is the ratio of the Aid flow (current US$) in Jordan in 2003 to that in 2007?
Your response must be concise. 0.43. What is the ratio of the Aid flow (current US$) of Mozambique in 2003 to that in 2007?
Offer a terse response. 0.58. What is the ratio of the Aid flow (current US$) of Thailand in 2003 to that in 2007?
Your answer should be very brief. 0.28. What is the ratio of the Aid flow (current US$) in Burkina Faso in 2003 to that in 2008?
Your answer should be very brief. 0.46. What is the ratio of the Aid flow (current US$) of Jordan in 2003 to that in 2008?
Your answer should be very brief. 0.43. What is the ratio of the Aid flow (current US$) in Mozambique in 2003 to that in 2008?
Your answer should be compact. 0.54. What is the ratio of the Aid flow (current US$) of Thailand in 2003 to that in 2008?
Give a very brief answer. 0.14. What is the ratio of the Aid flow (current US$) in Burkina Faso in 2003 to that in 2009?
Provide a succinct answer. 0.37. What is the ratio of the Aid flow (current US$) of Jordan in 2003 to that in 2009?
Provide a short and direct response. 0.6. What is the ratio of the Aid flow (current US$) in Mozambique in 2003 to that in 2009?
Make the answer very short. 0.62. What is the ratio of the Aid flow (current US$) in Jordan in 2004 to that in 2006?
Your answer should be compact. 0.04. What is the ratio of the Aid flow (current US$) of Mozambique in 2004 to that in 2006?
Provide a short and direct response. 0.9. What is the ratio of the Aid flow (current US$) of Thailand in 2004 to that in 2006?
Provide a short and direct response. 0.14. What is the ratio of the Aid flow (current US$) in Burkina Faso in 2004 to that in 2007?
Your answer should be very brief. 0.15. What is the ratio of the Aid flow (current US$) of Jordan in 2004 to that in 2007?
Ensure brevity in your answer.  0.07. What is the ratio of the Aid flow (current US$) of Mozambique in 2004 to that in 2007?
Your answer should be compact. 0.71. What is the ratio of the Aid flow (current US$) in Thailand in 2004 to that in 2007?
Your answer should be compact. 0.28. What is the ratio of the Aid flow (current US$) in Burkina Faso in 2004 to that in 2008?
Provide a succinct answer. 0.23. What is the ratio of the Aid flow (current US$) in Jordan in 2004 to that in 2008?
Offer a terse response. 0.07. What is the ratio of the Aid flow (current US$) of Mozambique in 2004 to that in 2008?
Offer a terse response. 0.66. What is the ratio of the Aid flow (current US$) of Thailand in 2004 to that in 2008?
Provide a short and direct response. 0.14. What is the ratio of the Aid flow (current US$) in Burkina Faso in 2004 to that in 2009?
Your answer should be compact. 0.18. What is the ratio of the Aid flow (current US$) of Jordan in 2004 to that in 2009?
Your response must be concise. 0.1. What is the ratio of the Aid flow (current US$) in Mozambique in 2004 to that in 2009?
Your answer should be compact. 0.76. What is the ratio of the Aid flow (current US$) of Burkina Faso in 2006 to that in 2007?
Your answer should be very brief. 0.08. What is the ratio of the Aid flow (current US$) in Jordan in 2006 to that in 2007?
Provide a short and direct response. 1.79. What is the ratio of the Aid flow (current US$) of Mozambique in 2006 to that in 2007?
Provide a short and direct response. 0.78. What is the ratio of the Aid flow (current US$) of Thailand in 2006 to that in 2007?
Your response must be concise. 1.94. What is the ratio of the Aid flow (current US$) in Burkina Faso in 2006 to that in 2008?
Keep it short and to the point. 0.11. What is the ratio of the Aid flow (current US$) of Jordan in 2006 to that in 2008?
Your response must be concise. 1.79. What is the ratio of the Aid flow (current US$) of Mozambique in 2006 to that in 2008?
Make the answer very short. 0.73. What is the ratio of the Aid flow (current US$) of Burkina Faso in 2006 to that in 2009?
Keep it short and to the point. 0.09. What is the ratio of the Aid flow (current US$) in Jordan in 2006 to that in 2009?
Offer a terse response. 2.5. What is the ratio of the Aid flow (current US$) of Mozambique in 2006 to that in 2009?
Offer a terse response. 0.84. What is the ratio of the Aid flow (current US$) in Thailand in 2006 to that in 2009?
Offer a terse response. 8.75. What is the ratio of the Aid flow (current US$) of Burkina Faso in 2007 to that in 2008?
Give a very brief answer. 1.49. What is the ratio of the Aid flow (current US$) of Mozambique in 2007 to that in 2008?
Keep it short and to the point. 0.93. What is the ratio of the Aid flow (current US$) in Thailand in 2007 to that in 2008?
Ensure brevity in your answer.  0.51. What is the ratio of the Aid flow (current US$) of Burkina Faso in 2007 to that in 2009?
Your response must be concise. 1.18. What is the ratio of the Aid flow (current US$) of Jordan in 2007 to that in 2009?
Offer a terse response. 1.4. What is the ratio of the Aid flow (current US$) of Mozambique in 2007 to that in 2009?
Make the answer very short. 1.08. What is the ratio of the Aid flow (current US$) in Burkina Faso in 2008 to that in 2009?
Your response must be concise. 0.79. What is the ratio of the Aid flow (current US$) of Jordan in 2008 to that in 2009?
Ensure brevity in your answer.  1.4. What is the ratio of the Aid flow (current US$) in Mozambique in 2008 to that in 2009?
Offer a terse response. 1.16. What is the ratio of the Aid flow (current US$) in Thailand in 2008 to that in 2009?
Give a very brief answer. 8.75. What is the difference between the highest and the second highest Aid flow (current US$) in Mozambique?
Provide a short and direct response. 5.46e+06. What is the difference between the highest and the lowest Aid flow (current US$) of Burkina Faso?
Provide a short and direct response. 9.80e+05. What is the difference between the highest and the lowest Aid flow (current US$) in Mozambique?
Your response must be concise. 6.77e+07. 